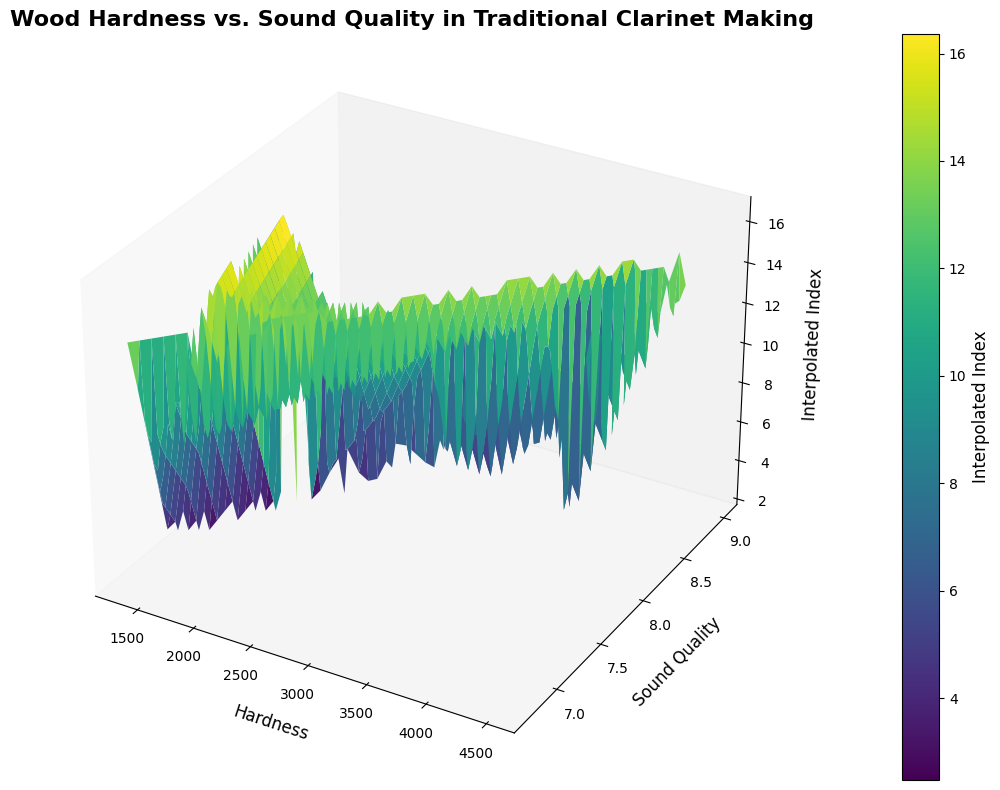Which type of wood has the highest hardness? Observe the data points on the x-axis labeled "Hardness". Identify the wood type with the maximum x-coordinate value on the plot.
Answer: Lignum Vitae Which type of wood has the lowest sound quality? Look for the data point with the minimum y-coordinate value labeled "Sound Quality" on the plot.
Answer: Olivewood Is the relation between hardness and sound quality linear or non-linear in the plot? Evaluate the general trend of the data points in the 3D surface plot to determine whether it forms a straight line (linear) or a curve (non-linear).
Answer: Non-linear What is the average hardness value across all wood types? Locate the x-axis 'Hardness' values for all wood types, sum them up and then divide by the number of wood types (17). Calculate (3680 + 1780 + 1380 + 3220 + 2960 + 3670 + 2400 + 1450 + 1610 + 2790 + 2200 + 3550 + 2810 + 1350 + 4500 + 1700 + 1800) / 17.
Answer: 2698.24 Which wood type has similar hardness to African Blackwood but differs in sound quality? Identify the hardness value for African Blackwood and then find other wood types with a similar hardness value. Compare their sound quality values on the y-axis.
Answer: Grenadilla Which type of wood has the highest interpolated index in the plot? Look for the highest point (peak) on the 3D surface plot z-axis, which indicates the highest interpolated index value.
Answer: Lignum Vitae Among Grenadilla, Rosewood, and Boxwood, which one has the best sound quality? Compare the y-coordinate values within these three wood types, focusing on "Sound Quality".
Answer: Grenadilla Does higher hardness always correlate with higher sound quality? Examine the general trend by comparing x-axis (hardness) to the y-axis (sound quality) for all data points to see if an increase in hardness consistently results in an increase in sound quality.
Answer: No On average, is the sound quality of wood types harder than 3000 higher than those softer than 3000? Separate the wood types based on hardness (>3000 and <=3000), then calculate the average sound quality for each group and compare them. Calculate [(3680, 8.5), (3220, 8.3), (3670, 8.6), (3550, 8.4), (4500, 9.0)] for >3000 and the rest for <=3000. Find the averages and compare.
Answer: Yes Which wood type lies at the intersection of hardwood and medium sound quality in the plot? Identify the wood type approximately in the middle of the hardness range and medium range of sound quality on the 3D plot.
Answer: Cocobolo 